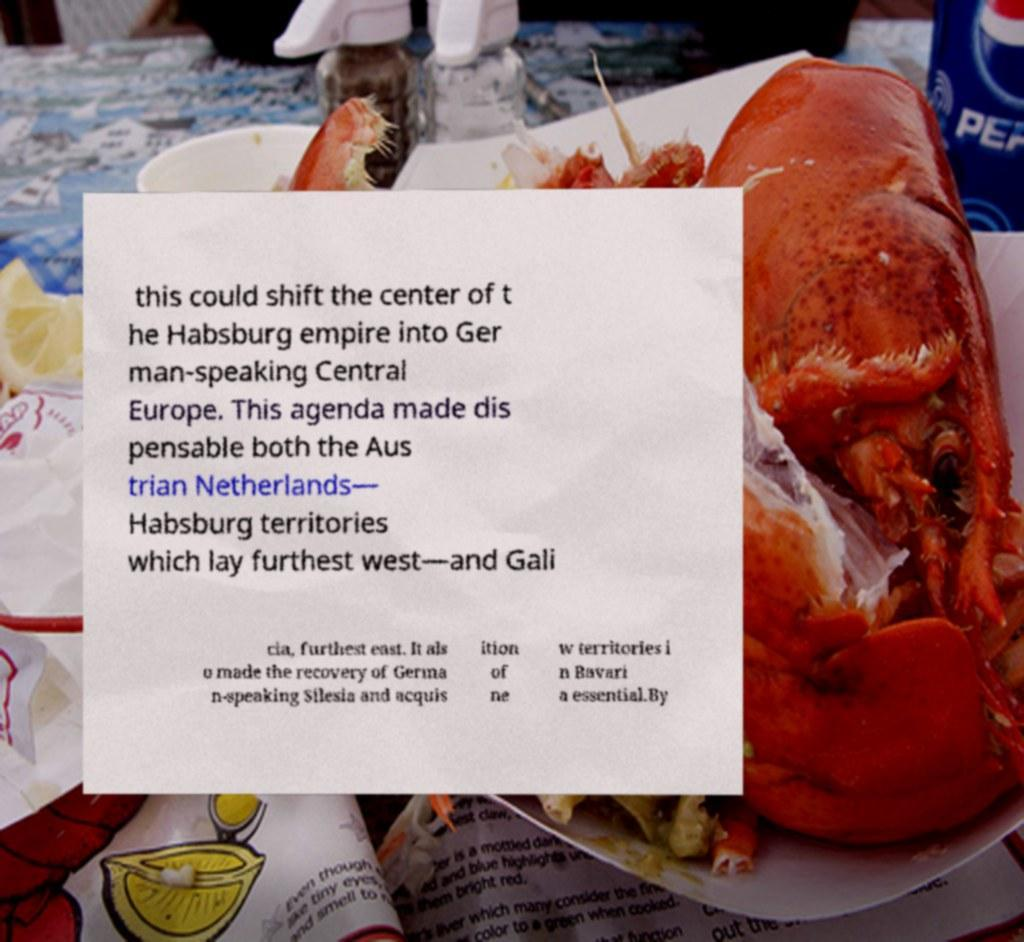Could you extract and type out the text from this image? this could shift the center of t he Habsburg empire into Ger man-speaking Central Europe. This agenda made dis pensable both the Aus trian Netherlands— Habsburg territories which lay furthest west—and Gali cia, furthest east. It als o made the recovery of Germa n-speaking Silesia and acquis ition of ne w territories i n Bavari a essential.By 